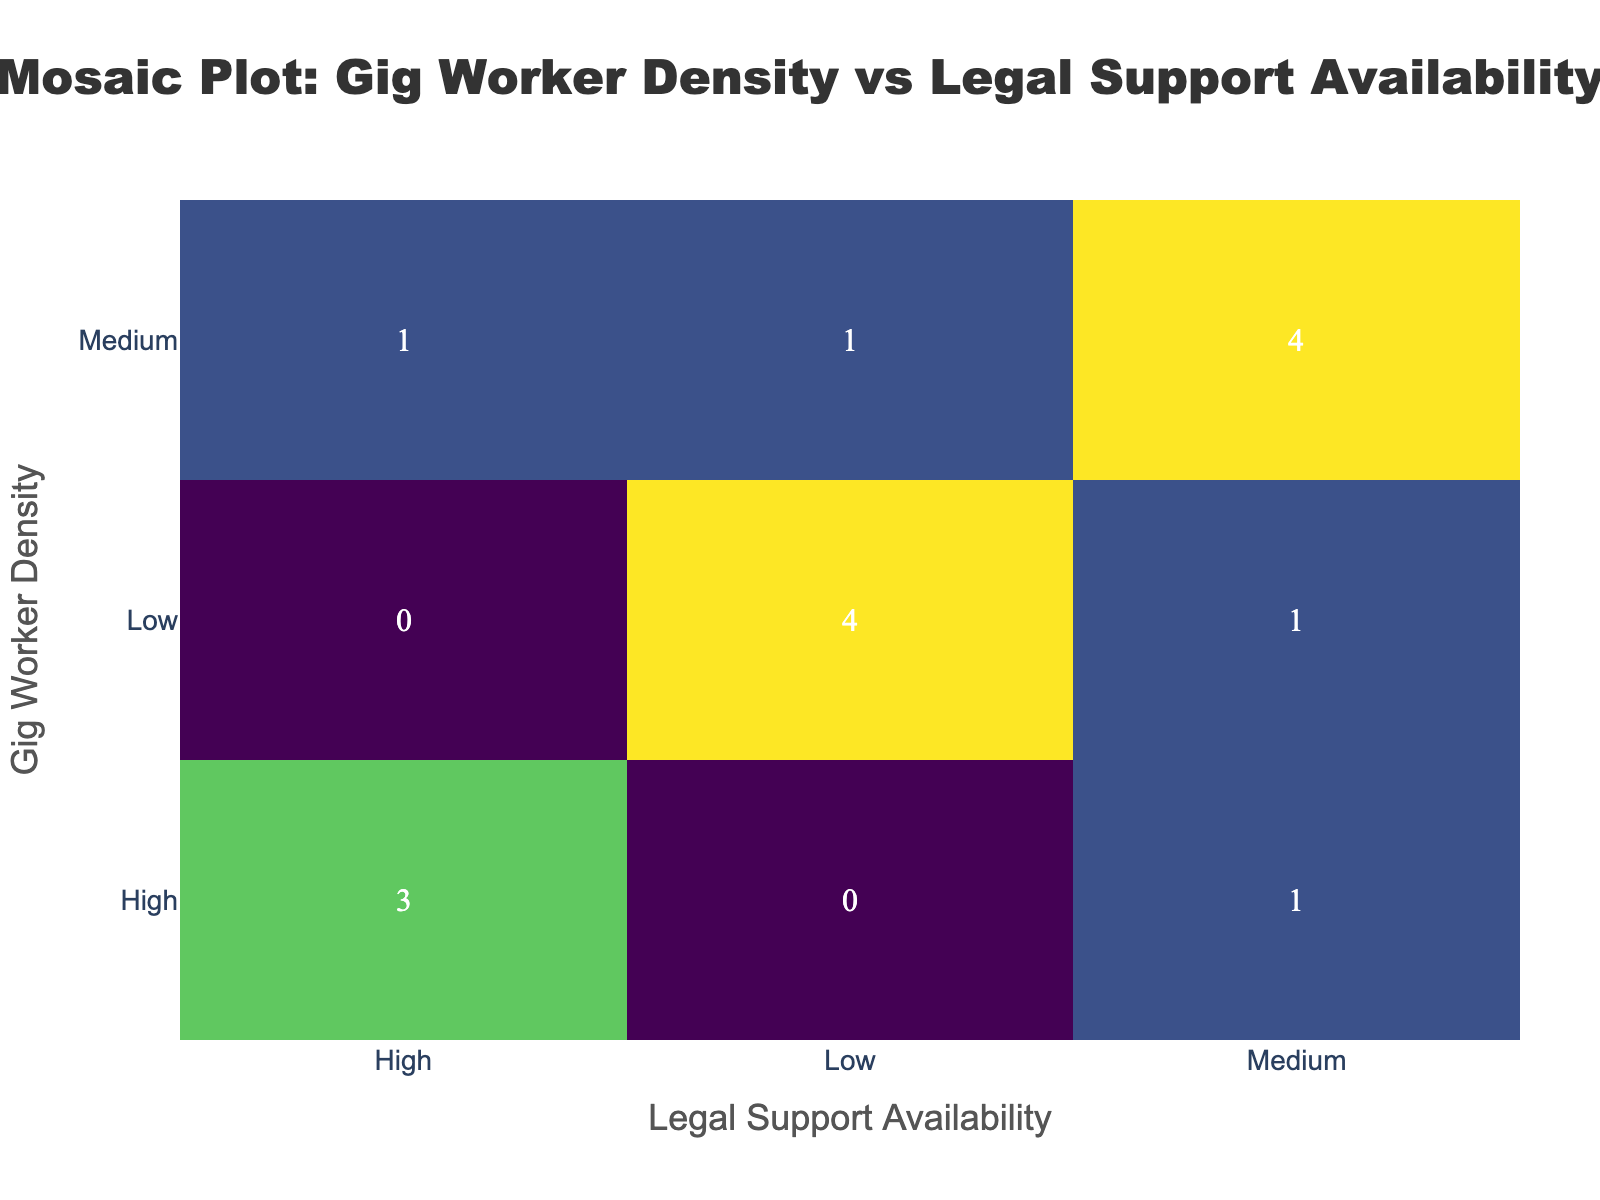What are the axis titles on the plot? The plot has two axis titles. The x-axis title is 'Legal Support Availability', and the y-axis title is 'Gig Worker Density'.
Answer: Legal Support Availability, Gig Worker Density How many regions have a high gig worker density and high legal support availability? Look at the intersection of 'High' for both gig worker density and legal support availability in the plot, and read the value, which is 3.
Answer: 3 Which gig worker density category has the lowest number of regions with low legal support availability? By comparing the values in the 'Low' column for each gig worker density category, it's clear that the high category has 0 regions, the medium category has 1 region, and the low category has 4 regions. Therefore, the high category has the lowest number.
Answer: High What is the total number of regions with medium legal support availability? Add up the numbers in the 'Medium' column: 0 (High) + 5 (Medium) + 1 (Low) = 6.
Answer: 6 Does any category have an equal number of regions in any two distinct gig worker density and legal support combinations? In the plot, compare the values in each combination of columns and rows. The medium density and medium legal support (5) is equal to the low density and low legal support (4).
Answer: No What's the difference between the number of regions with medium gig worker density and medium legal support availability and those with low gig worker density and low legal support availability? The medium gig worker density and medium legal support availability count is 5, and the low gig worker density and low legal support availability count is 4. The difference is 5 - 4 = 1.
Answer: 1 How many total regions are included in the plot? Add up all the values in the plot: (3 + 0 + 1) + (0 + 5 + 5) + (4 + 1 + 4) = 3 + 0 + 1 + 0 + 5 + 5 + 4 + 1 + 4 = 21.
Answer: 21 